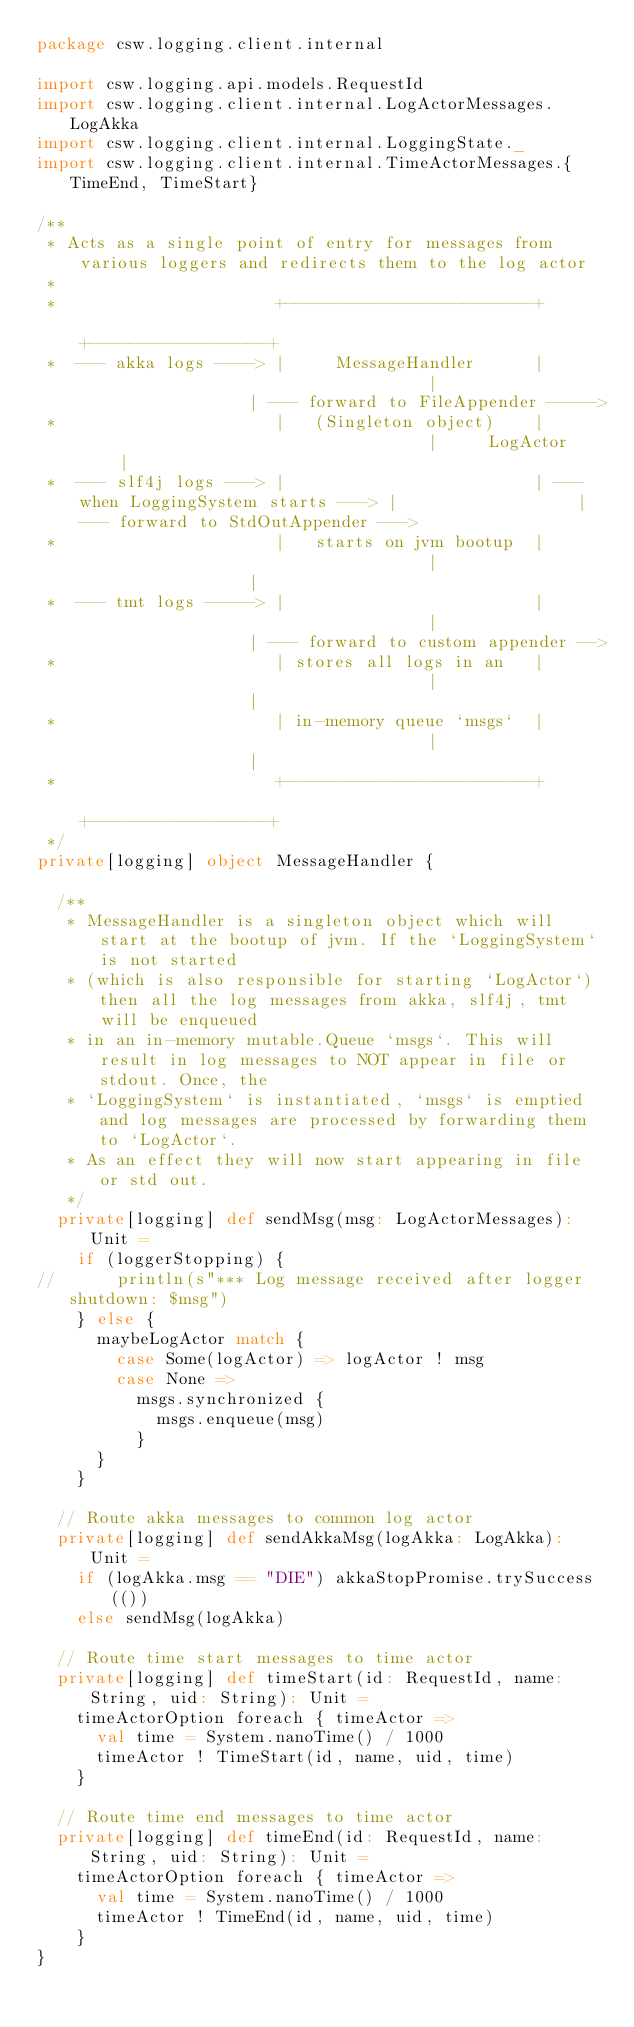Convert code to text. <code><loc_0><loc_0><loc_500><loc_500><_Scala_>package csw.logging.client.internal

import csw.logging.api.models.RequestId
import csw.logging.client.internal.LogActorMessages.LogAkka
import csw.logging.client.internal.LoggingState._
import csw.logging.client.internal.TimeActorMessages.{TimeEnd, TimeStart}

/**
 * Acts as a single point of entry for messages from various loggers and redirects them to the log actor
 *
 *                      +-------------------------+                                    +------------------+
 *  --- akka logs ----> |     MessageHandler      |                                    |                  | --- forward to FileAppender ----->
 *                      |   (Singleton object)    |                                    |     LogActor     |
 *  --- slf4j logs ---> |                         | --- when LoggingSystem starts ---> |                  | --- forward to StdOutAppender --->
 *                      |   starts on jvm bootup  |                                    |                  |
 *  --- tmt logs -----> |                         |                                    |                  | --- forward to custom appender -->
 *                      | stores all logs in an   |                                    |                  |
 *                      | in-memory queue `msgs`  |                                    |                  |
 *                      +-------------------------+                                    +------------------+
 */
private[logging] object MessageHandler {

  /**
   * MessageHandler is a singleton object which will start at the bootup of jvm. If the `LoggingSystem` is not started
   * (which is also responsible for starting `LogActor`) then all the log messages from akka, slf4j, tmt will be enqueued
   * in an in-memory mutable.Queue `msgs`. This will result in log messages to NOT appear in file or stdout. Once, the
   * `LoggingSystem` is instantiated, `msgs` is emptied and log messages are processed by forwarding them to `LogActor`.
   * As an effect they will now start appearing in file or std out.
   */
  private[logging] def sendMsg(msg: LogActorMessages): Unit =
    if (loggerStopping) {
//      println(s"*** Log message received after logger shutdown: $msg")
    } else {
      maybeLogActor match {
        case Some(logActor) => logActor ! msg
        case None =>
          msgs.synchronized {
            msgs.enqueue(msg)
          }
      }
    }

  // Route akka messages to common log actor
  private[logging] def sendAkkaMsg(logAkka: LogAkka): Unit =
    if (logAkka.msg == "DIE") akkaStopPromise.trySuccess(())
    else sendMsg(logAkka)

  // Route time start messages to time actor
  private[logging] def timeStart(id: RequestId, name: String, uid: String): Unit =
    timeActorOption foreach { timeActor =>
      val time = System.nanoTime() / 1000
      timeActor ! TimeStart(id, name, uid, time)
    }

  // Route time end messages to time actor
  private[logging] def timeEnd(id: RequestId, name: String, uid: String): Unit =
    timeActorOption foreach { timeActor =>
      val time = System.nanoTime() / 1000
      timeActor ! TimeEnd(id, name, uid, time)
    }
}
</code> 